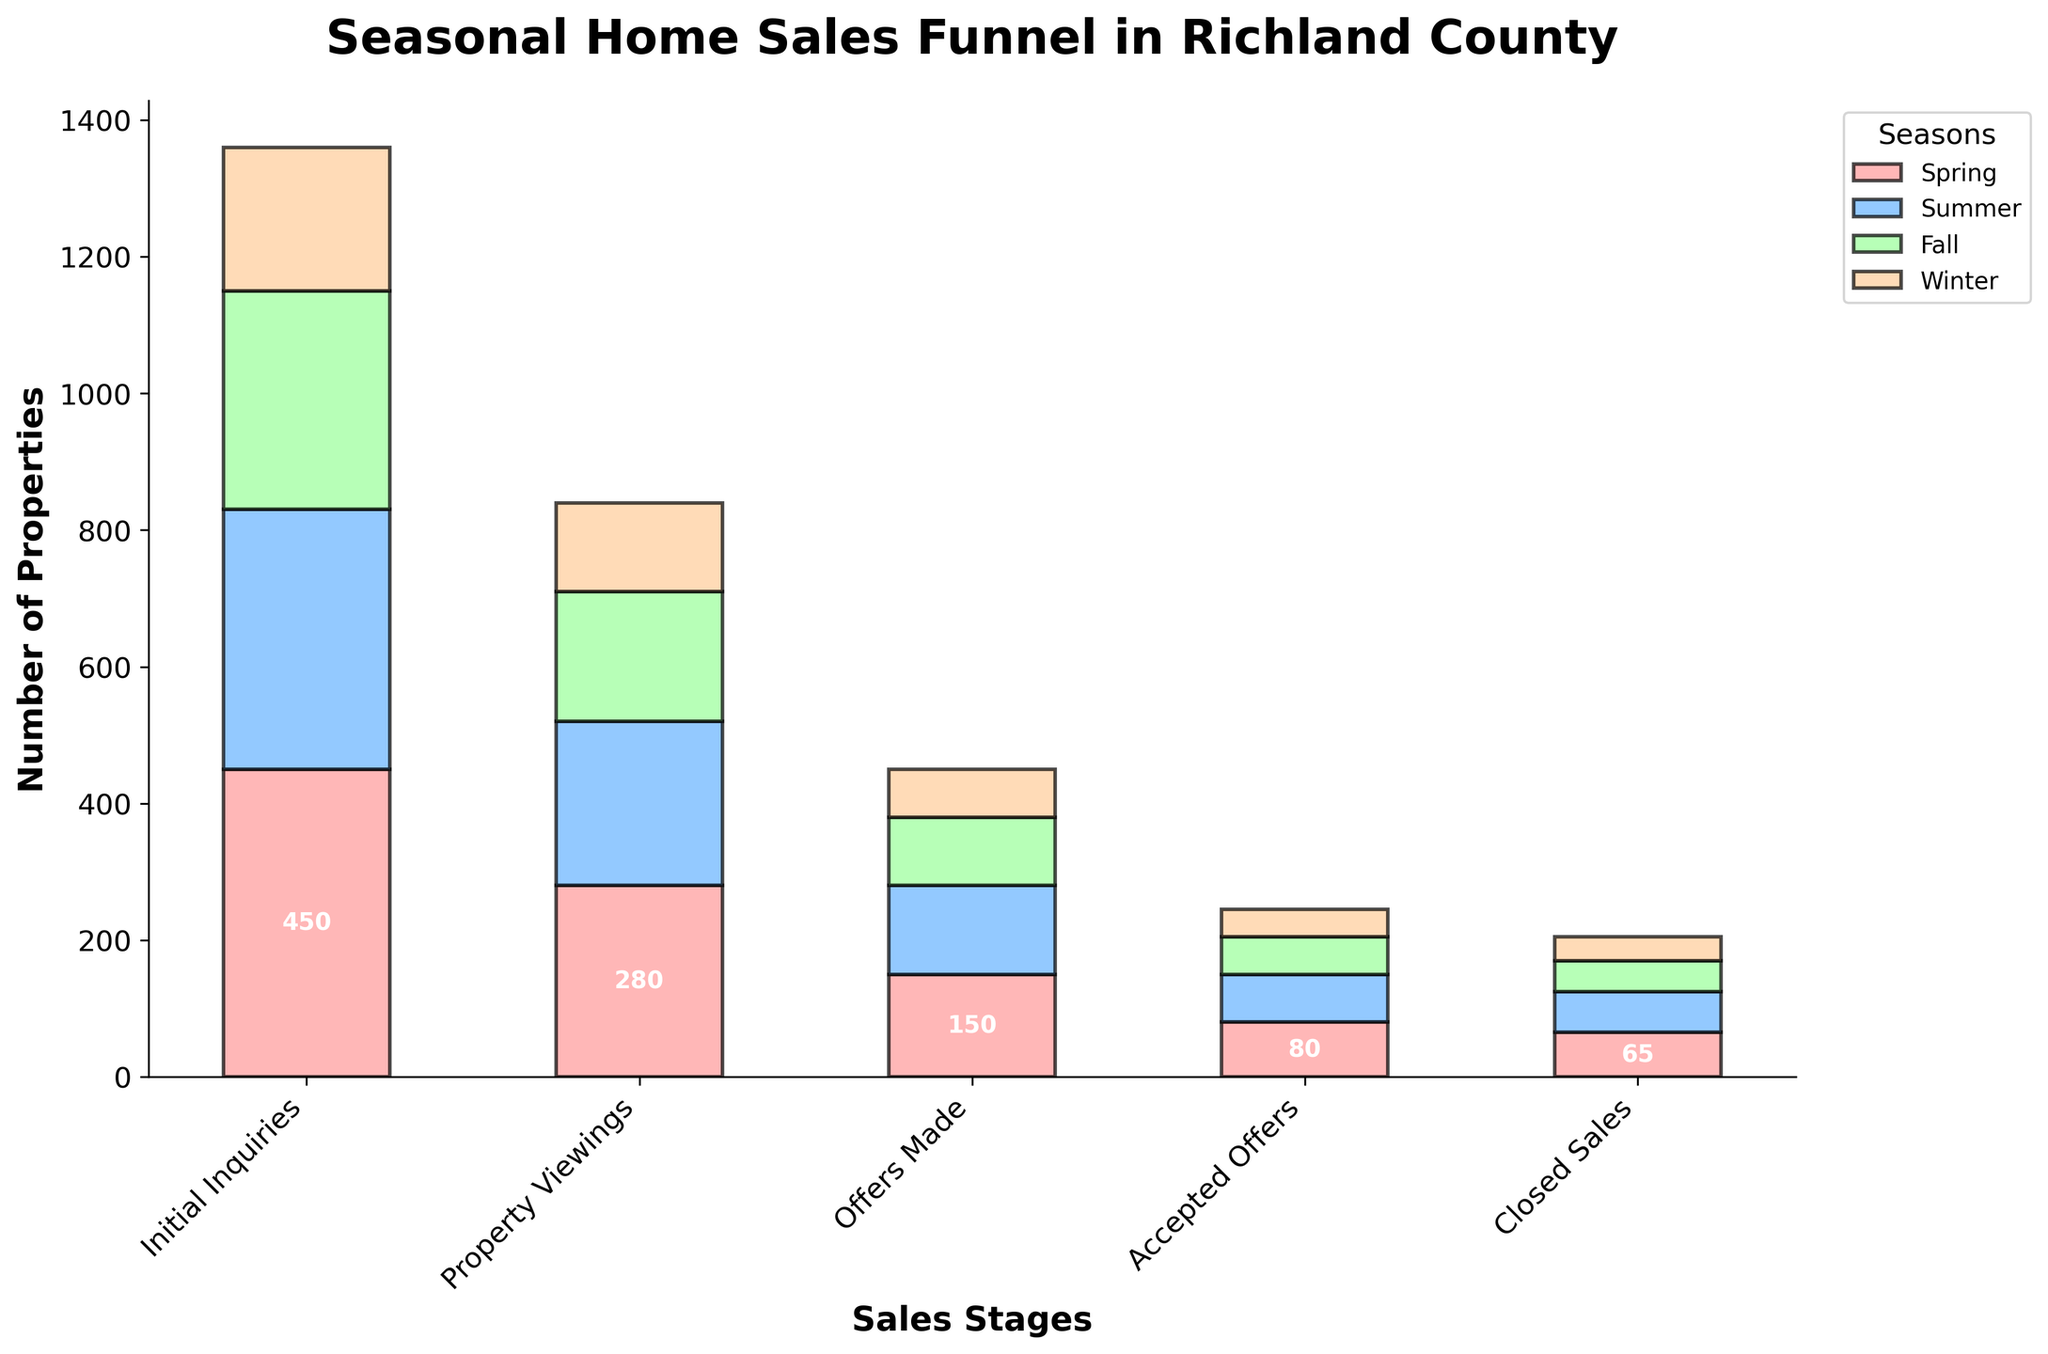What is the title of the figure? The title is usually located at the top of the figure and is typically larger and bolder than other text. The title here is "Seasonal Home Sales Funnel in Richland County".
Answer: Seasonal Home Sales Funnel in Richland County What are the labels on the X and Y axes? The X-axis label can be found below the horizontal axis, and the Y-axis label can be found next to the vertical axis. In the figure, the X-axis is labeled "Sales Stages" and the Y-axis is labeled "Number of Properties".
Answer: Sales Stages, Number of Properties Which season had the highest number of Initial Inquiries? By comparing the bar heights for the "Initial Inquiries" stage, we see that Spring has the tallest bar with 450 inquiries. Thus, Spring had the highest number of Initial Inquiries.
Answer: Spring At which stage do the numbers for each season start to converge? By examining the stages from Initial Inquiries to Closed Sales, we can see that the numbers for each season become closer at the "Accepted Offers" and "Closed Sales" stages, indicating they start to converge there.
Answer: Accepted Offers How many more Property Viewings were there in Spring compared to Winter? To find this, we subtract the number of Winter Property Viewings from the number of Spring Property Viewings: 280 - 130. This results in 150 more viewings in Spring.
Answer: 150 What's the difference between the number of Offers Made in Summer and Fall? By subtracting the number of Offers Made in Fall from those in Summer: 130 - 100, we find that there were 30 more Offers Made in Summer.
Answer: 30 Which stage has the smallest drop in numbers from Spring to Summer? We compare the drops between each stage's counts for Spring and Summer. The smallest drop is seen in the "Closed Sales" stage, from 65 to 60, which is a drop of 5.
Answer: Closed Sales What is the total number of Closed Sales across all seasons? Summing up the number of Closed Sales for each season: 65 (Spring) + 60 (Summer) + 45 (Fall) + 35 (Winter), the total number of Closed Sales is 205.
Answer: 205 How does the funnel change from Initial Inquiries to Closed Sales in Fall? By observing Fall's values across stages: Initial Inquiries (320), Property Viewings (190), Offers Made (100), Accepted Offers (55), Closed Sales (45), we see a decreasing trend showing fewer properties making it further down each stage of the funnel.
Answer: Decreasing trend 